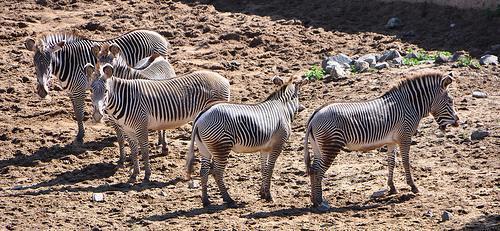How many zebras are there?
Give a very brief answer. 5. 